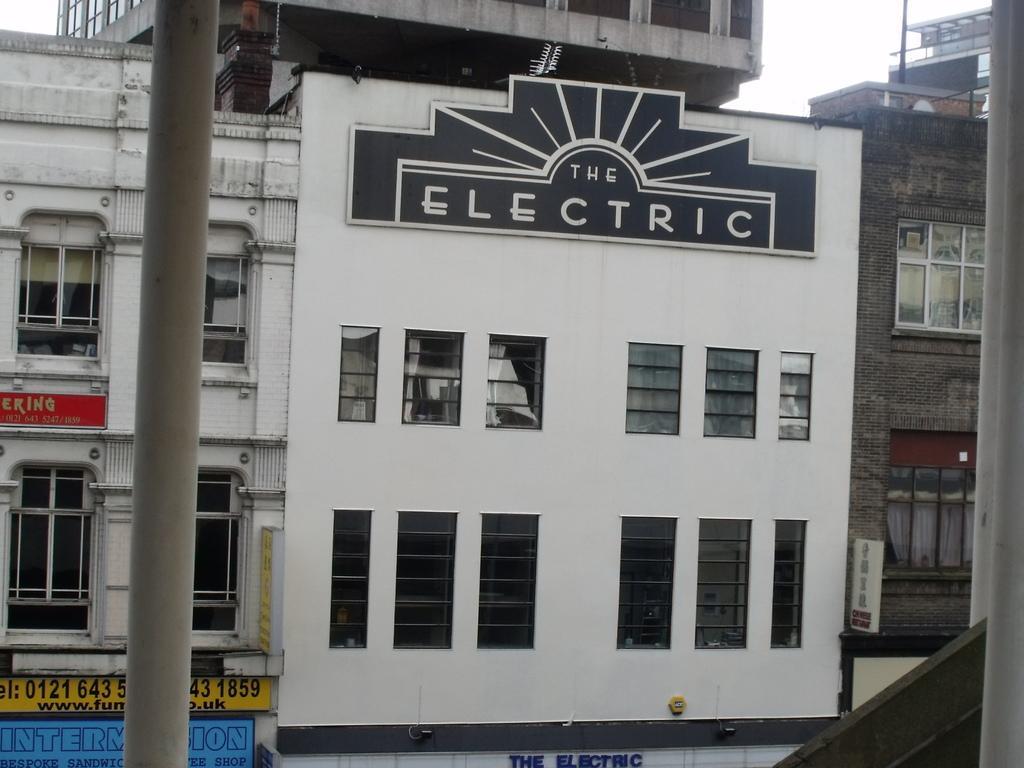Please provide a concise description of this image. This image consists of buildings along with windows. At the top, there is sky. On the left, we can see a pole. 